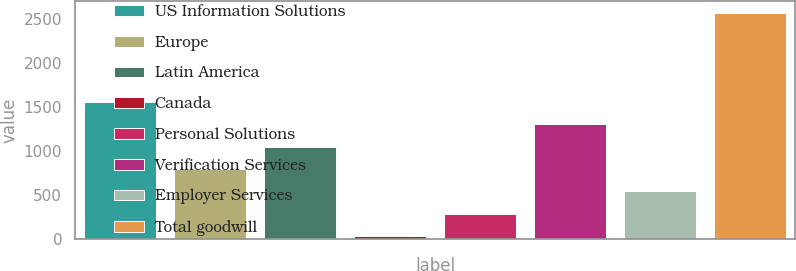<chart> <loc_0><loc_0><loc_500><loc_500><bar_chart><fcel>US Information Solutions<fcel>Europe<fcel>Latin America<fcel>Canada<fcel>Personal Solutions<fcel>Verification Services<fcel>Employer Services<fcel>Total goodwill<nl><fcel>1555.44<fcel>793.77<fcel>1047.66<fcel>32.1<fcel>285.99<fcel>1301.55<fcel>539.88<fcel>2571<nl></chart> 